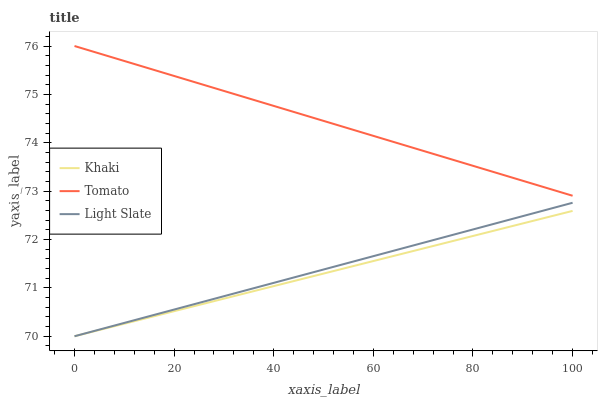Does Khaki have the minimum area under the curve?
Answer yes or no. Yes. Does Tomato have the maximum area under the curve?
Answer yes or no. Yes. Does Light Slate have the minimum area under the curve?
Answer yes or no. No. Does Light Slate have the maximum area under the curve?
Answer yes or no. No. Is Tomato the smoothest?
Answer yes or no. Yes. Is Khaki the roughest?
Answer yes or no. Yes. Is Light Slate the smoothest?
Answer yes or no. No. Is Light Slate the roughest?
Answer yes or no. No. Does Light Slate have the lowest value?
Answer yes or no. Yes. Does Tomato have the highest value?
Answer yes or no. Yes. Does Light Slate have the highest value?
Answer yes or no. No. Is Khaki less than Tomato?
Answer yes or no. Yes. Is Tomato greater than Light Slate?
Answer yes or no. Yes. Does Khaki intersect Light Slate?
Answer yes or no. Yes. Is Khaki less than Light Slate?
Answer yes or no. No. Is Khaki greater than Light Slate?
Answer yes or no. No. Does Khaki intersect Tomato?
Answer yes or no. No. 